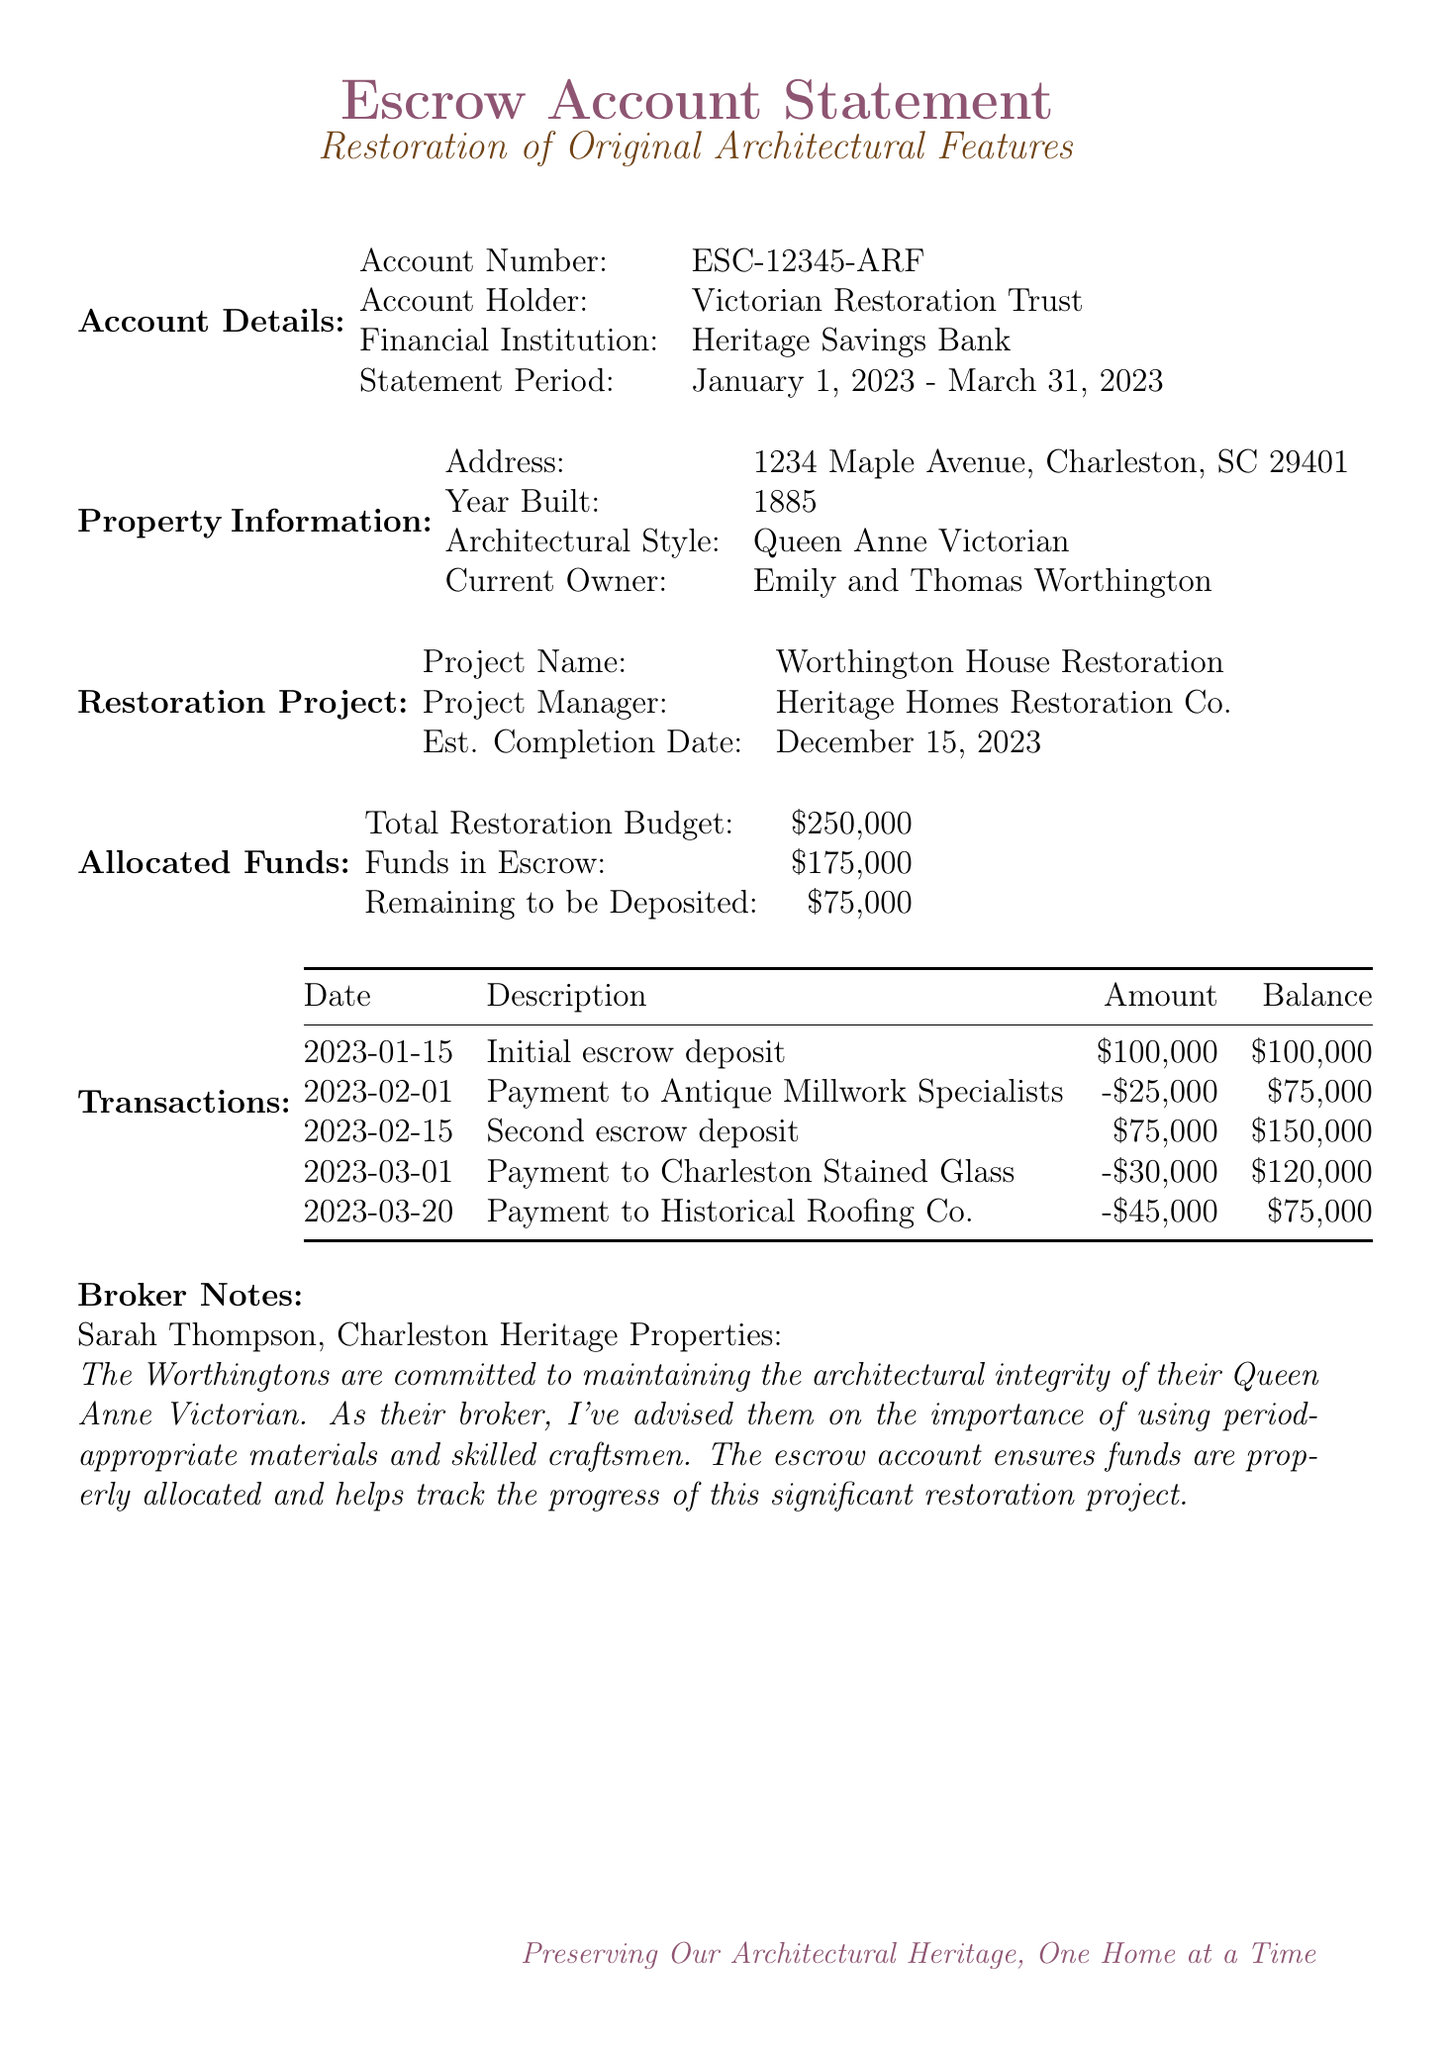what is the account number? The account number for the escrow account is listed in the document.
Answer: ESC-12345-ARF who is the project manager? The document specifies the name of the project manager for the restoration project.
Answer: Heritage Homes Restoration Co what is the estimated cost for original hardwood flooring? The estimated cost for restoring the original hardwood flooring is mentioned in the restoration features section.
Answer: 35000 when was the second escrow deposit made? The date of the second escrow deposit is provided in the transactions section.
Answer: 2023-02-15 what is the total restoration budget? The total restoration budget is clearly stated in the allocated funds section of the document.
Answer: 250000 how much funds are currently in escrow? The amount of funds currently held in escrow is provided in the allocated funds section.
Answer: 175000 what is required before starting the restoration project? The document outlines the approvals necessary before proceeding with the restoration project.
Answer: Certificate of Appropriateness what is the completion date for the restoration project? The estimated completion date for the restoration project is stated within the restoration project section.
Answer: December 15, 2023 who are the current owners of the property? The names of the current owners are mentioned in the property information section of the document.
Answer: Emily and Thomas Worthington 